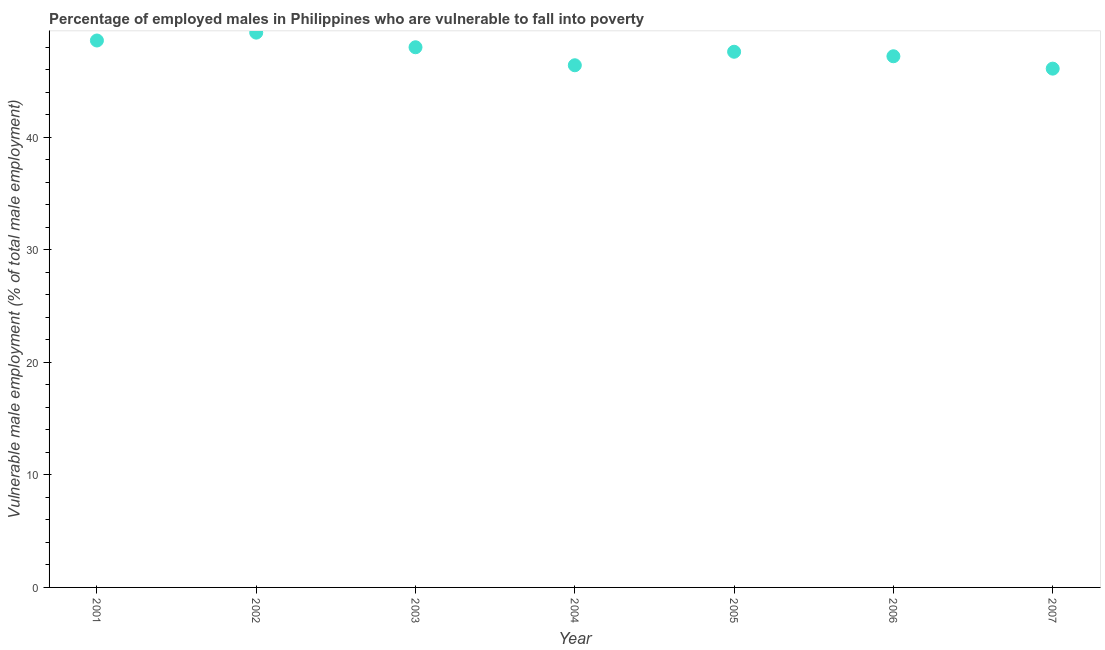Across all years, what is the maximum percentage of employed males who are vulnerable to fall into poverty?
Provide a succinct answer. 49.3. Across all years, what is the minimum percentage of employed males who are vulnerable to fall into poverty?
Offer a very short reply. 46.1. In which year was the percentage of employed males who are vulnerable to fall into poverty minimum?
Ensure brevity in your answer.  2007. What is the sum of the percentage of employed males who are vulnerable to fall into poverty?
Give a very brief answer. 333.2. What is the difference between the percentage of employed males who are vulnerable to fall into poverty in 2003 and 2007?
Offer a terse response. 1.9. What is the average percentage of employed males who are vulnerable to fall into poverty per year?
Keep it short and to the point. 47.6. What is the median percentage of employed males who are vulnerable to fall into poverty?
Offer a terse response. 47.6. Do a majority of the years between 2005 and 2002 (inclusive) have percentage of employed males who are vulnerable to fall into poverty greater than 6 %?
Keep it short and to the point. Yes. What is the ratio of the percentage of employed males who are vulnerable to fall into poverty in 2005 to that in 2006?
Offer a terse response. 1.01. Is the percentage of employed males who are vulnerable to fall into poverty in 2003 less than that in 2006?
Make the answer very short. No. What is the difference between the highest and the second highest percentage of employed males who are vulnerable to fall into poverty?
Provide a short and direct response. 0.7. What is the difference between the highest and the lowest percentage of employed males who are vulnerable to fall into poverty?
Provide a short and direct response. 3.2. In how many years, is the percentage of employed males who are vulnerable to fall into poverty greater than the average percentage of employed males who are vulnerable to fall into poverty taken over all years?
Your response must be concise. 3. What is the difference between two consecutive major ticks on the Y-axis?
Give a very brief answer. 10. Does the graph contain grids?
Provide a succinct answer. No. What is the title of the graph?
Provide a short and direct response. Percentage of employed males in Philippines who are vulnerable to fall into poverty. What is the label or title of the X-axis?
Make the answer very short. Year. What is the label or title of the Y-axis?
Offer a very short reply. Vulnerable male employment (% of total male employment). What is the Vulnerable male employment (% of total male employment) in 2001?
Provide a short and direct response. 48.6. What is the Vulnerable male employment (% of total male employment) in 2002?
Your answer should be very brief. 49.3. What is the Vulnerable male employment (% of total male employment) in 2004?
Offer a very short reply. 46.4. What is the Vulnerable male employment (% of total male employment) in 2005?
Offer a very short reply. 47.6. What is the Vulnerable male employment (% of total male employment) in 2006?
Make the answer very short. 47.2. What is the Vulnerable male employment (% of total male employment) in 2007?
Your response must be concise. 46.1. What is the difference between the Vulnerable male employment (% of total male employment) in 2001 and 2002?
Your response must be concise. -0.7. What is the difference between the Vulnerable male employment (% of total male employment) in 2001 and 2003?
Your answer should be very brief. 0.6. What is the difference between the Vulnerable male employment (% of total male employment) in 2001 and 2005?
Your response must be concise. 1. What is the difference between the Vulnerable male employment (% of total male employment) in 2001 and 2006?
Your answer should be compact. 1.4. What is the difference between the Vulnerable male employment (% of total male employment) in 2001 and 2007?
Make the answer very short. 2.5. What is the difference between the Vulnerable male employment (% of total male employment) in 2002 and 2003?
Offer a very short reply. 1.3. What is the difference between the Vulnerable male employment (% of total male employment) in 2002 and 2005?
Ensure brevity in your answer.  1.7. What is the difference between the Vulnerable male employment (% of total male employment) in 2002 and 2006?
Offer a very short reply. 2.1. What is the difference between the Vulnerable male employment (% of total male employment) in 2002 and 2007?
Provide a short and direct response. 3.2. What is the difference between the Vulnerable male employment (% of total male employment) in 2003 and 2004?
Give a very brief answer. 1.6. What is the difference between the Vulnerable male employment (% of total male employment) in 2003 and 2006?
Provide a succinct answer. 0.8. What is the difference between the Vulnerable male employment (% of total male employment) in 2004 and 2006?
Your response must be concise. -0.8. What is the ratio of the Vulnerable male employment (% of total male employment) in 2001 to that in 2002?
Make the answer very short. 0.99. What is the ratio of the Vulnerable male employment (% of total male employment) in 2001 to that in 2003?
Keep it short and to the point. 1.01. What is the ratio of the Vulnerable male employment (% of total male employment) in 2001 to that in 2004?
Your answer should be very brief. 1.05. What is the ratio of the Vulnerable male employment (% of total male employment) in 2001 to that in 2005?
Your response must be concise. 1.02. What is the ratio of the Vulnerable male employment (% of total male employment) in 2001 to that in 2007?
Ensure brevity in your answer.  1.05. What is the ratio of the Vulnerable male employment (% of total male employment) in 2002 to that in 2003?
Offer a terse response. 1.03. What is the ratio of the Vulnerable male employment (% of total male employment) in 2002 to that in 2004?
Your response must be concise. 1.06. What is the ratio of the Vulnerable male employment (% of total male employment) in 2002 to that in 2005?
Provide a short and direct response. 1.04. What is the ratio of the Vulnerable male employment (% of total male employment) in 2002 to that in 2006?
Give a very brief answer. 1.04. What is the ratio of the Vulnerable male employment (% of total male employment) in 2002 to that in 2007?
Give a very brief answer. 1.07. What is the ratio of the Vulnerable male employment (% of total male employment) in 2003 to that in 2004?
Ensure brevity in your answer.  1.03. What is the ratio of the Vulnerable male employment (% of total male employment) in 2003 to that in 2005?
Give a very brief answer. 1.01. What is the ratio of the Vulnerable male employment (% of total male employment) in 2003 to that in 2006?
Your answer should be compact. 1.02. What is the ratio of the Vulnerable male employment (% of total male employment) in 2003 to that in 2007?
Your response must be concise. 1.04. What is the ratio of the Vulnerable male employment (% of total male employment) in 2004 to that in 2005?
Offer a terse response. 0.97. What is the ratio of the Vulnerable male employment (% of total male employment) in 2004 to that in 2006?
Provide a succinct answer. 0.98. What is the ratio of the Vulnerable male employment (% of total male employment) in 2005 to that in 2007?
Give a very brief answer. 1.03. What is the ratio of the Vulnerable male employment (% of total male employment) in 2006 to that in 2007?
Your answer should be compact. 1.02. 